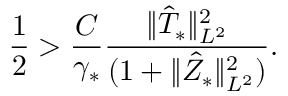Convert formula to latex. <formula><loc_0><loc_0><loc_500><loc_500>\frac { 1 } { 2 } > \frac { C } { \gamma _ { * } } \frac { \| \hat { T } _ { * } \| _ { L ^ { 2 } } ^ { 2 } } { ( 1 + \| \hat { Z } _ { * } \| _ { L ^ { 2 } } ^ { 2 } ) } .</formula> 